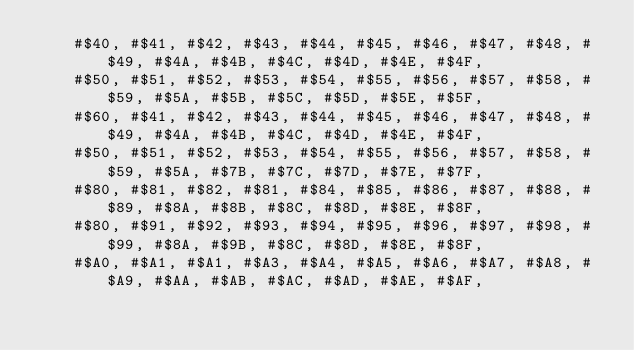Convert code to text. <code><loc_0><loc_0><loc_500><loc_500><_Pascal_>    #$40, #$41, #$42, #$43, #$44, #$45, #$46, #$47, #$48, #$49, #$4A, #$4B, #$4C, #$4D, #$4E, #$4F,
    #$50, #$51, #$52, #$53, #$54, #$55, #$56, #$57, #$58, #$59, #$5A, #$5B, #$5C, #$5D, #$5E, #$5F,
    #$60, #$41, #$42, #$43, #$44, #$45, #$46, #$47, #$48, #$49, #$4A, #$4B, #$4C, #$4D, #$4E, #$4F,
    #$50, #$51, #$52, #$53, #$54, #$55, #$56, #$57, #$58, #$59, #$5A, #$7B, #$7C, #$7D, #$7E, #$7F,
    #$80, #$81, #$82, #$81, #$84, #$85, #$86, #$87, #$88, #$89, #$8A, #$8B, #$8C, #$8D, #$8E, #$8F,
    #$80, #$91, #$92, #$93, #$94, #$95, #$96, #$97, #$98, #$99, #$8A, #$9B, #$8C, #$8D, #$8E, #$8F,
    #$A0, #$A1, #$A1, #$A3, #$A4, #$A5, #$A6, #$A7, #$A8, #$A9, #$AA, #$AB, #$AC, #$AD, #$AE, #$AF,</code> 